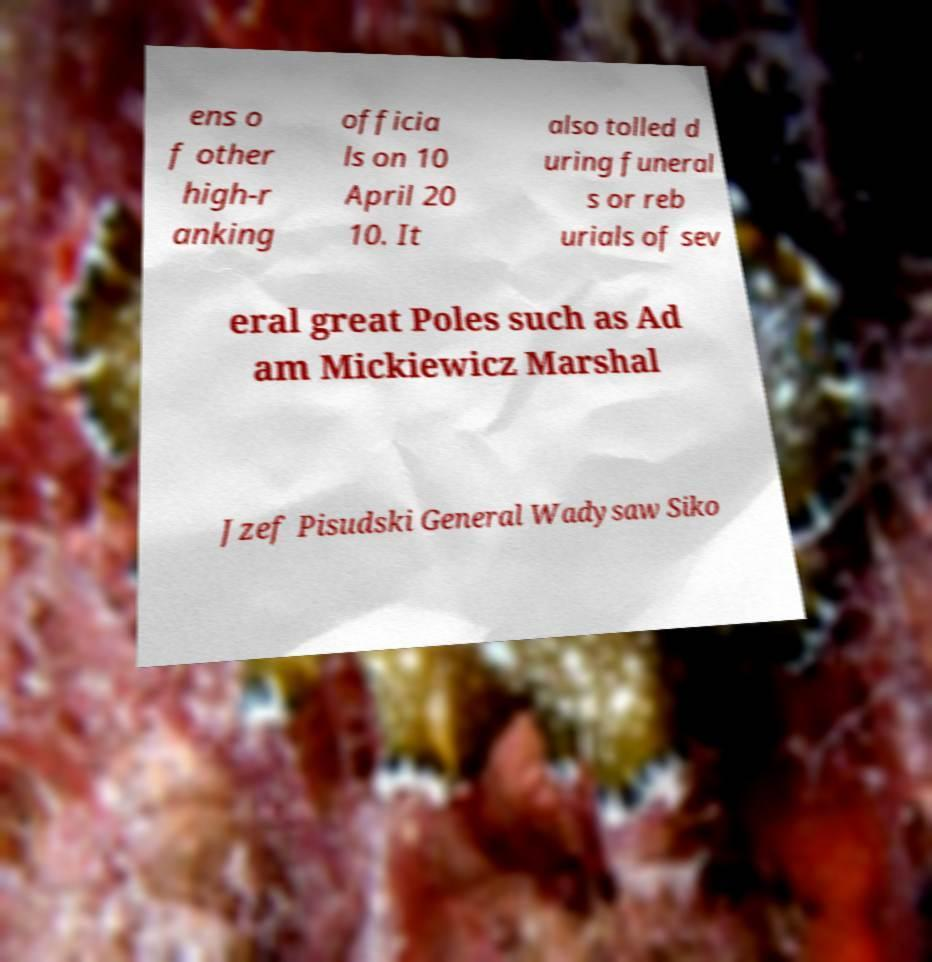I need the written content from this picture converted into text. Can you do that? ens o f other high-r anking officia ls on 10 April 20 10. It also tolled d uring funeral s or reb urials of sev eral great Poles such as Ad am Mickiewicz Marshal Jzef Pisudski General Wadysaw Siko 